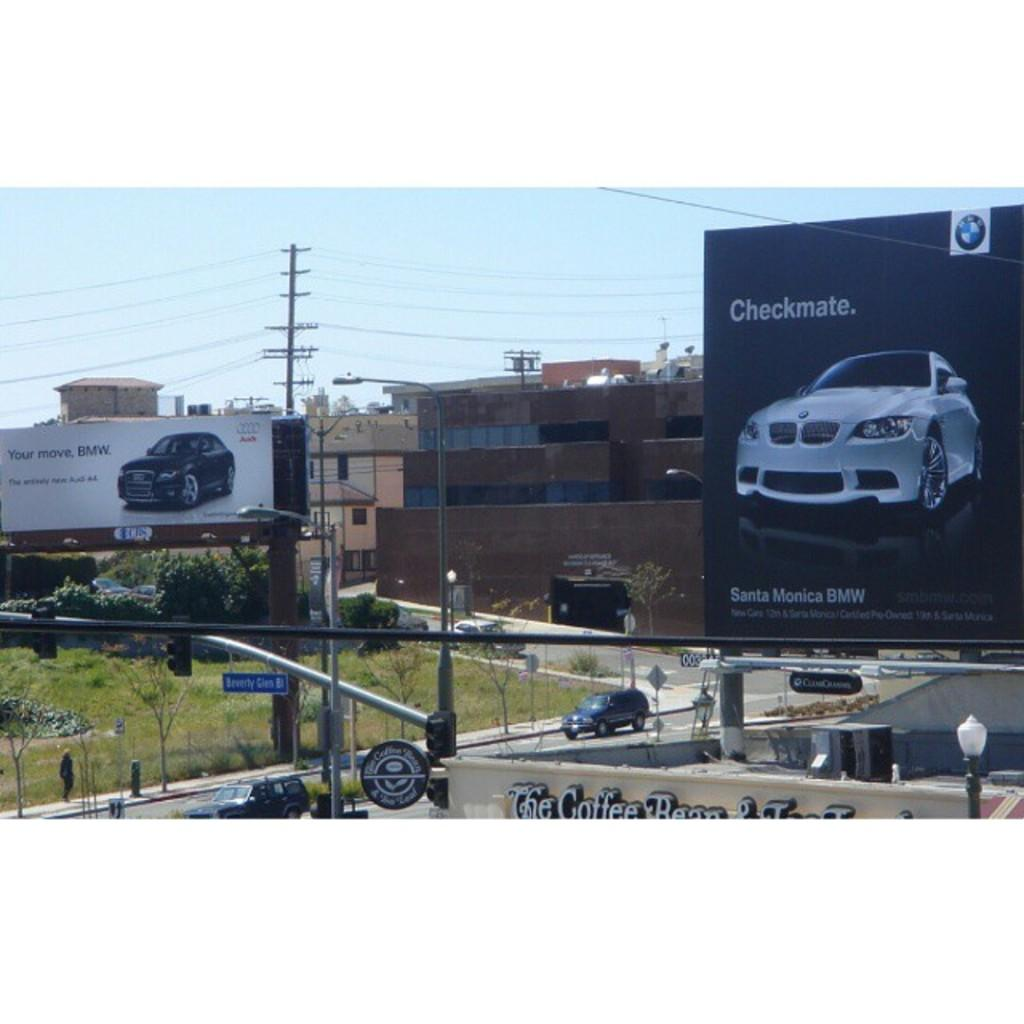What can be seen moving on the road in the image? There are vehicles on the road, and a person is walking on the road. What type of signage is present in the image? There are banners in the image. What structures are supporting the banners and other objects in the image? There are poles in the image. What is the name of the place or establishment in the image? There is a name board in the image. What architectural feature can be seen on the buildings in the image? There are buildings with windows in the image. What type of vegetation is present in the image? There are trees in the image. What can be seen in the background of the image? The sky is visible in the background of the image. Can you tell me how many bees are sitting on the name board in the image? There are no bees present on the name board or anywhere else in the image. What type of vest is the father wearing in the image? There is no father or vest present in the image. 